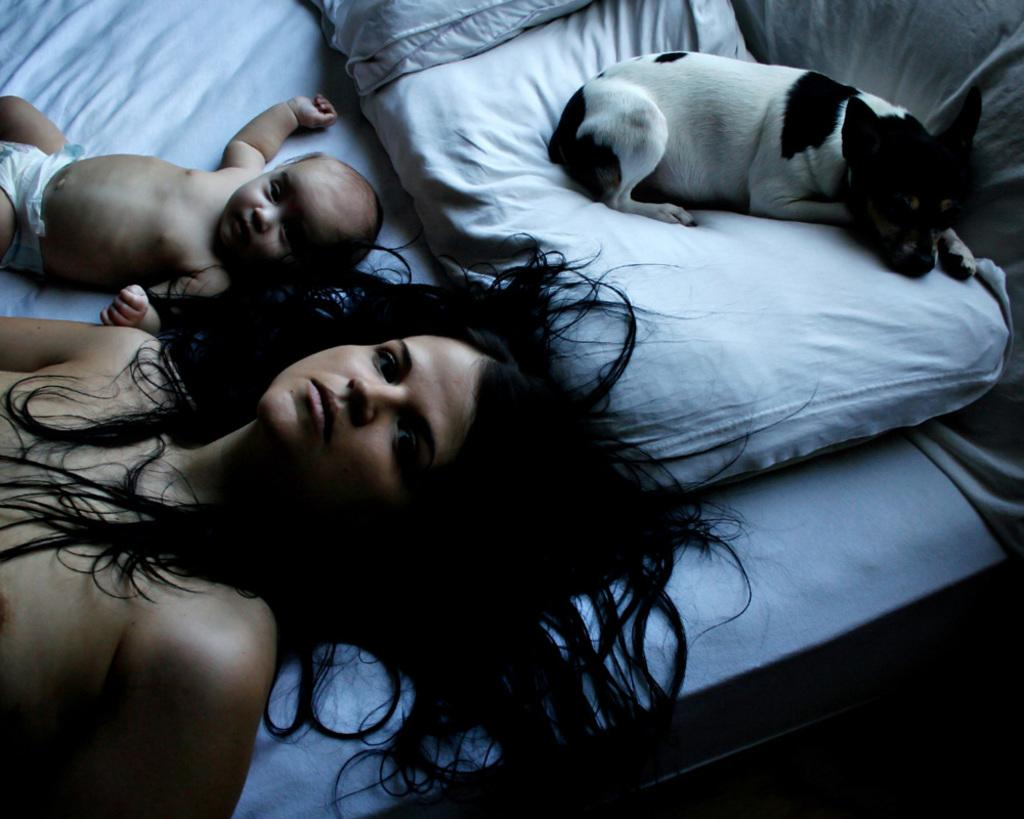Who is present in the image? There is a woman and a baby in the image. What other living creature can be seen in the image? There is a dog in the image. What is the woman and baby sitting on in the image? There are pillows on the bed in the image. In which direction is the unit facing in the image? There is no unit present in the image, so it is not possible to determine the direction it might be facing. 